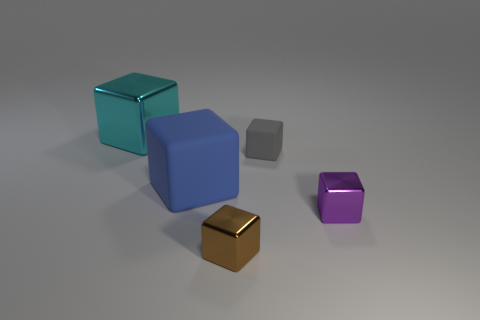Subtract all tiny brown metallic blocks. How many blocks are left? 4 Subtract all cyan cubes. How many cubes are left? 4 Subtract 1 cubes. How many cubes are left? 4 Subtract all yellow cubes. Subtract all green cylinders. How many cubes are left? 5 Add 1 tiny metallic objects. How many objects exist? 6 Subtract 0 red blocks. How many objects are left? 5 Subtract all large cyan metallic things. Subtract all small gray metal blocks. How many objects are left? 4 Add 2 small rubber cubes. How many small rubber cubes are left? 3 Add 2 large blue balls. How many large blue balls exist? 2 